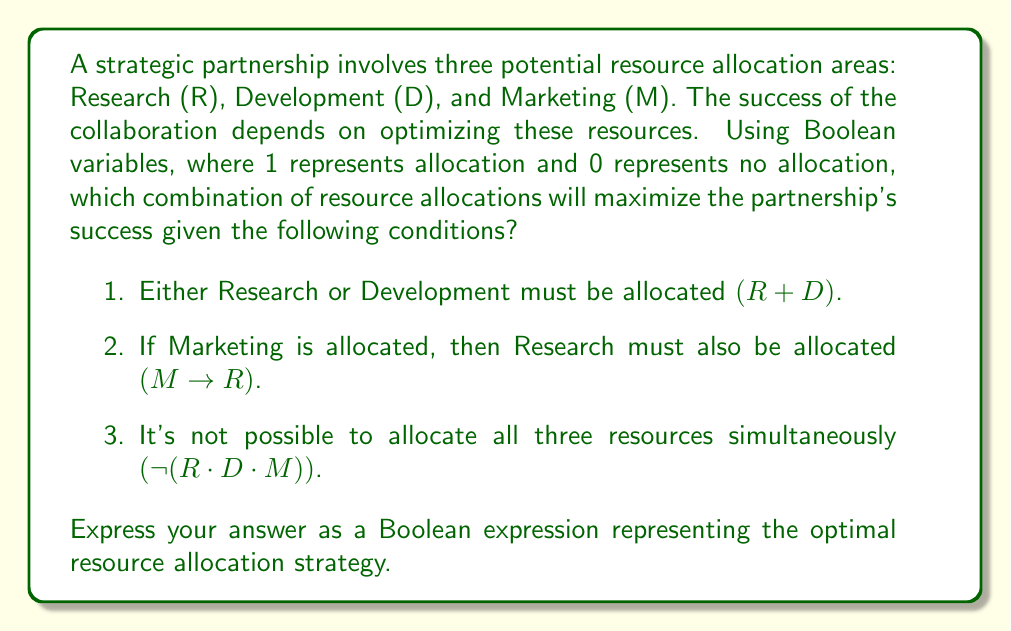Show me your answer to this math problem. Let's approach this step-by-step using Boolean algebra:

1) First, we need to satisfy condition 1: R + D must be true. This means we have three possible combinations: (1,0,0), (0,1,0), or (1,1,0) for (R,D,M).

2) Now, let's consider condition 2: M → R. This can be rewritten as ¬M + R in Boolean algebra. This condition eliminates the possibility of allocating marketing without research.

3) Condition 3 states ¬(R · D · M), which means we can't have all three as 1.

4) Combining these conditions, we get:
   $$(R + D) \cdot (¬M + R) \cdot ¬(R \cdot D \cdot M)$$

5) Expanding this expression:
   $$(R + D) \cdot (¬M + R) \cdot (¬R + ¬D + ¬M)$$

6) The optimal allocation should maximize the number of resources while satisfying all conditions. From our analysis in steps 1-3, we can deduce that the optimal allocation is (1,1,0) for (R,D,M).

7) This allocation satisfies all conditions:
   - R + D is true (condition 1)
   - M → R is true (condition 2, trivially satisfied when M is 0)
   - ¬(R · D · M) is true (condition 3, as M is 0)

8) We can express this optimal allocation as a Boolean expression:
   $$R \cdot D \cdot ¬M$$

This expression represents allocating resources to Research and Development, but not to Marketing.
Answer: $$R \cdot D \cdot ¬M$$ 